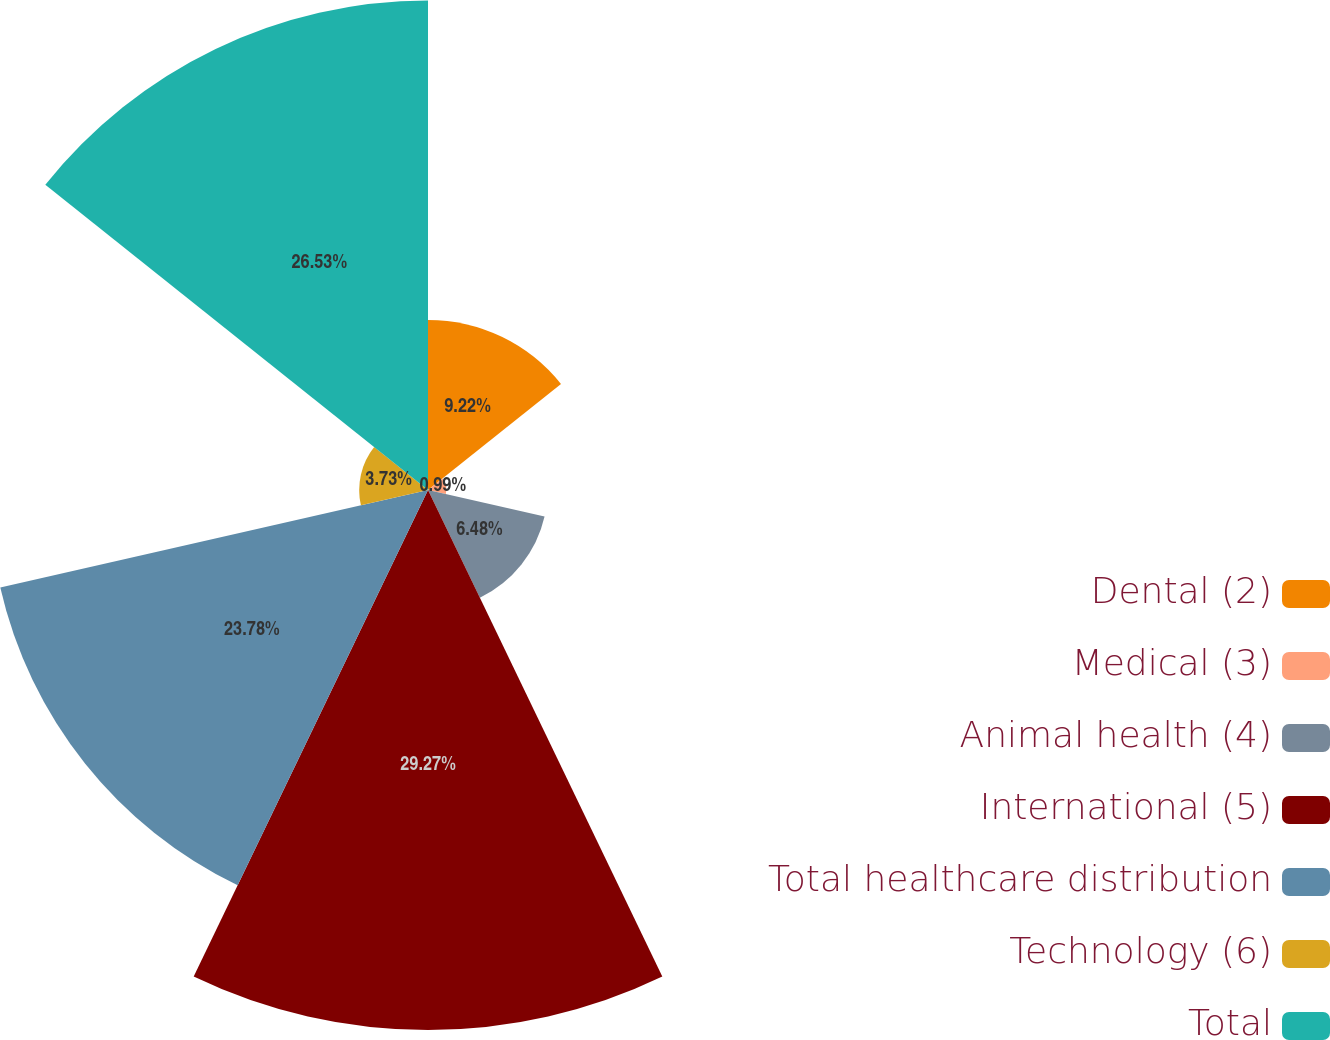Convert chart to OTSL. <chart><loc_0><loc_0><loc_500><loc_500><pie_chart><fcel>Dental (2)<fcel>Medical (3)<fcel>Animal health (4)<fcel>International (5)<fcel>Total healthcare distribution<fcel>Technology (6)<fcel>Total<nl><fcel>9.22%<fcel>0.99%<fcel>6.48%<fcel>29.27%<fcel>23.78%<fcel>3.73%<fcel>26.53%<nl></chart> 